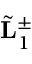<formula> <loc_0><loc_0><loc_500><loc_500>\tilde { L } _ { 1 } ^ { \pm }</formula> 